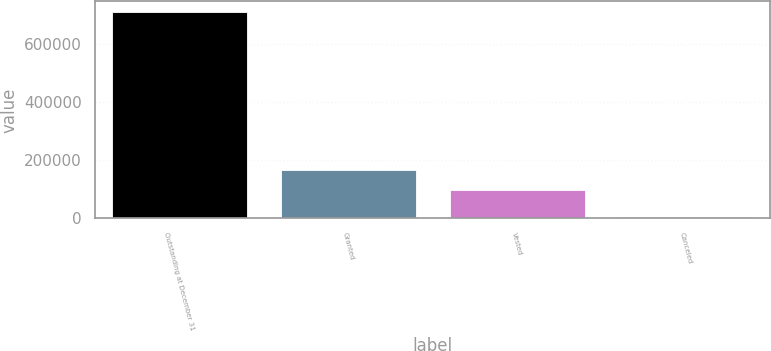<chart> <loc_0><loc_0><loc_500><loc_500><bar_chart><fcel>Outstanding at December 31<fcel>Granted<fcel>Vested<fcel>Canceled<nl><fcel>712469<fcel>165425<fcel>99318<fcel>3466<nl></chart> 